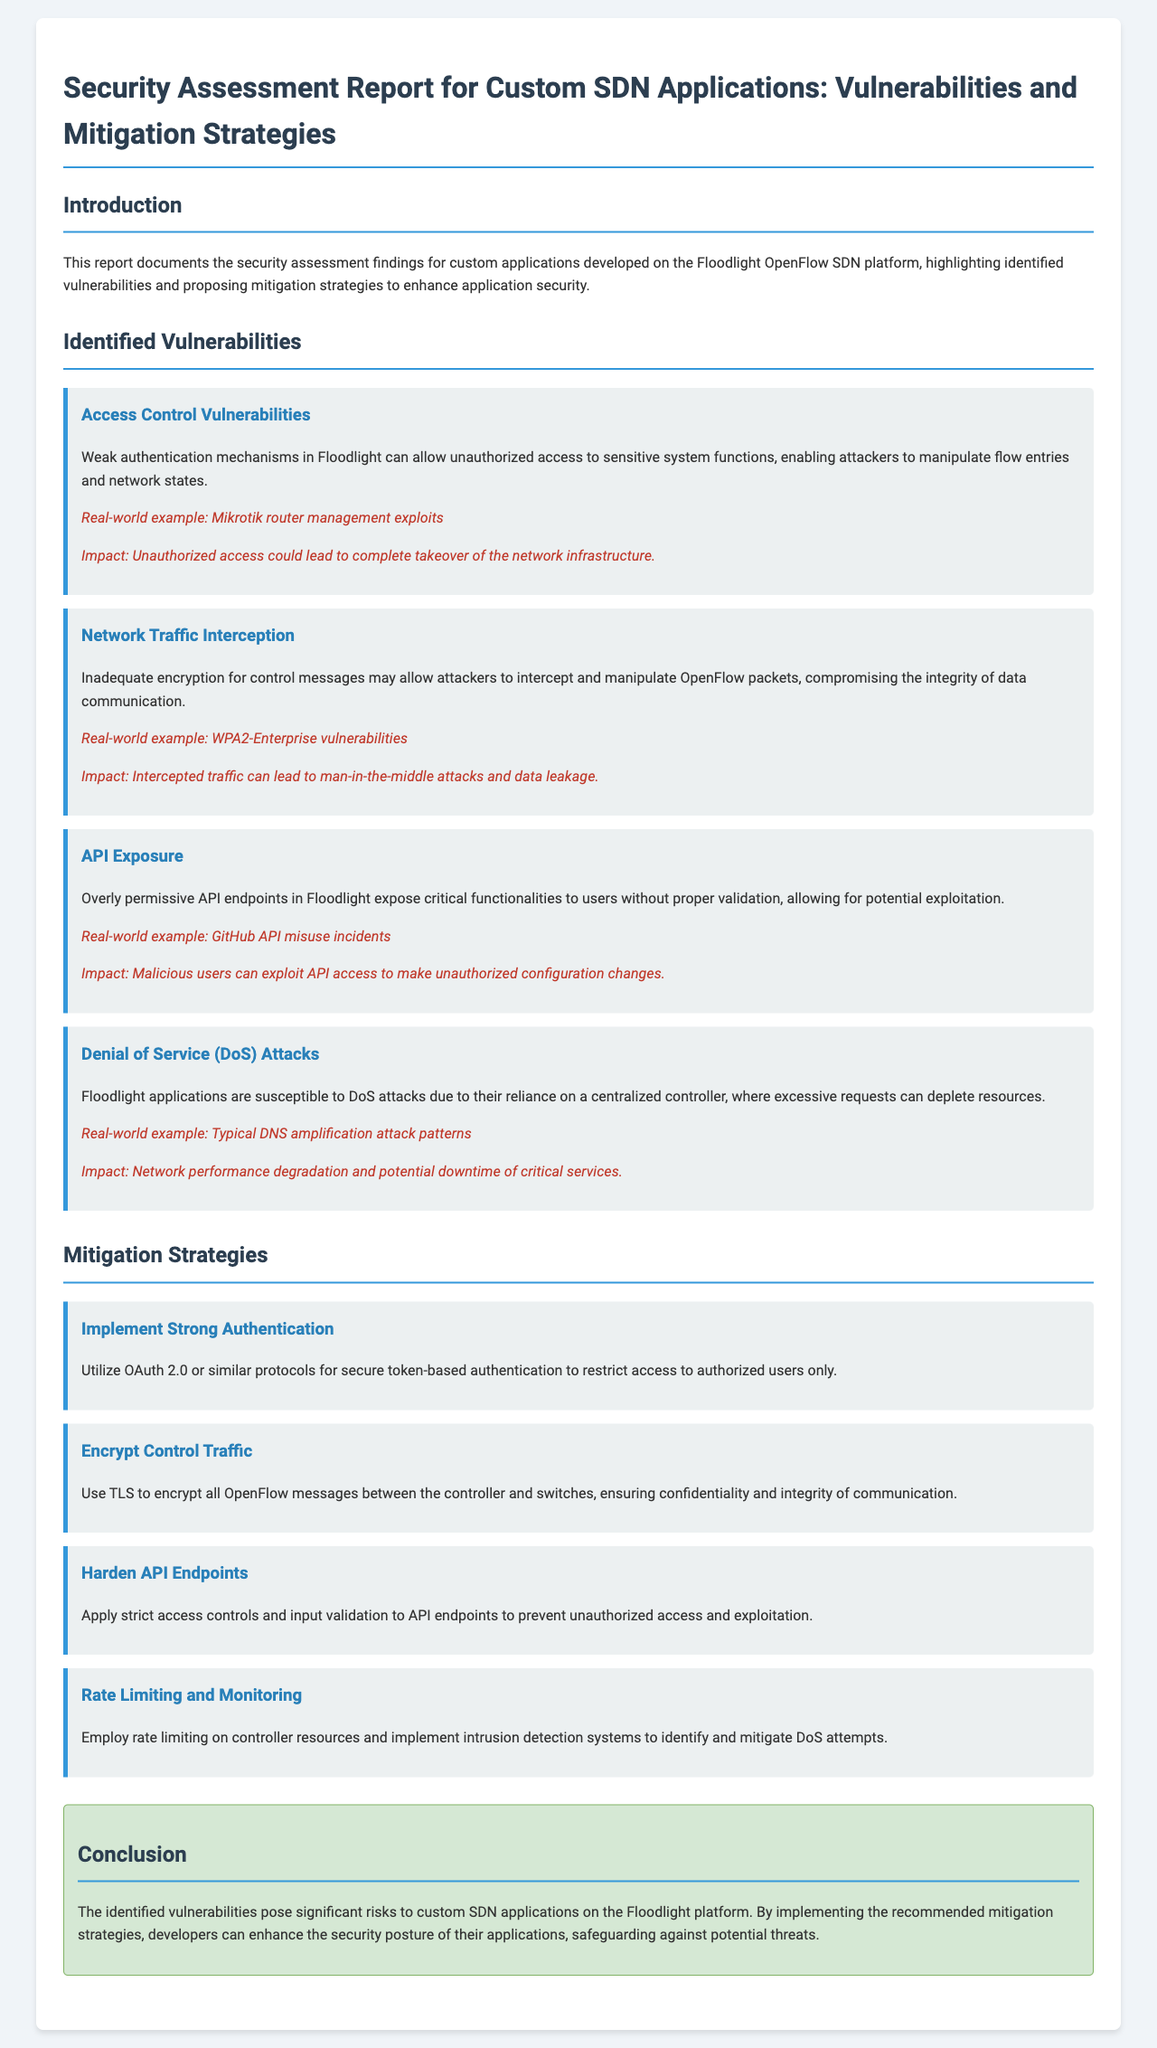What are the identified vulnerabilities? The document lists several identified vulnerabilities in custom SDN applications, including Access Control Vulnerabilities, Network Traffic Interception, API Exposure, and Denial of Service Attacks.
Answer: Access Control Vulnerabilities, Network Traffic Interception, API Exposure, Denial of Service Attacks What is the proposed mitigation strategy for APIs? The document outlines various mitigation strategies, specifying the need to harden API endpoints as a strategy to prevent unauthorized access and exploitation.
Answer: Harden API Endpoints What impact does unauthorized access have? The impact of unauthorized access is specifically outlined in the section regarding Access Control Vulnerabilities, indicating it could lead to complete takeover of the network infrastructure.
Answer: Complete takeover of the network infrastructure What encryption is recommended for control traffic? The document recommends using TLS to encrypt traffic, ensuring confidentiality and integrity of data communication between the controller and switches.
Answer: TLS What real-world example is associated with network traffic interception? A real-world example mentioned in relation to inadequate encryption for control messages is the WPA2-Enterprise vulnerabilities.
Answer: WPA2-Enterprise vulnerabilities 